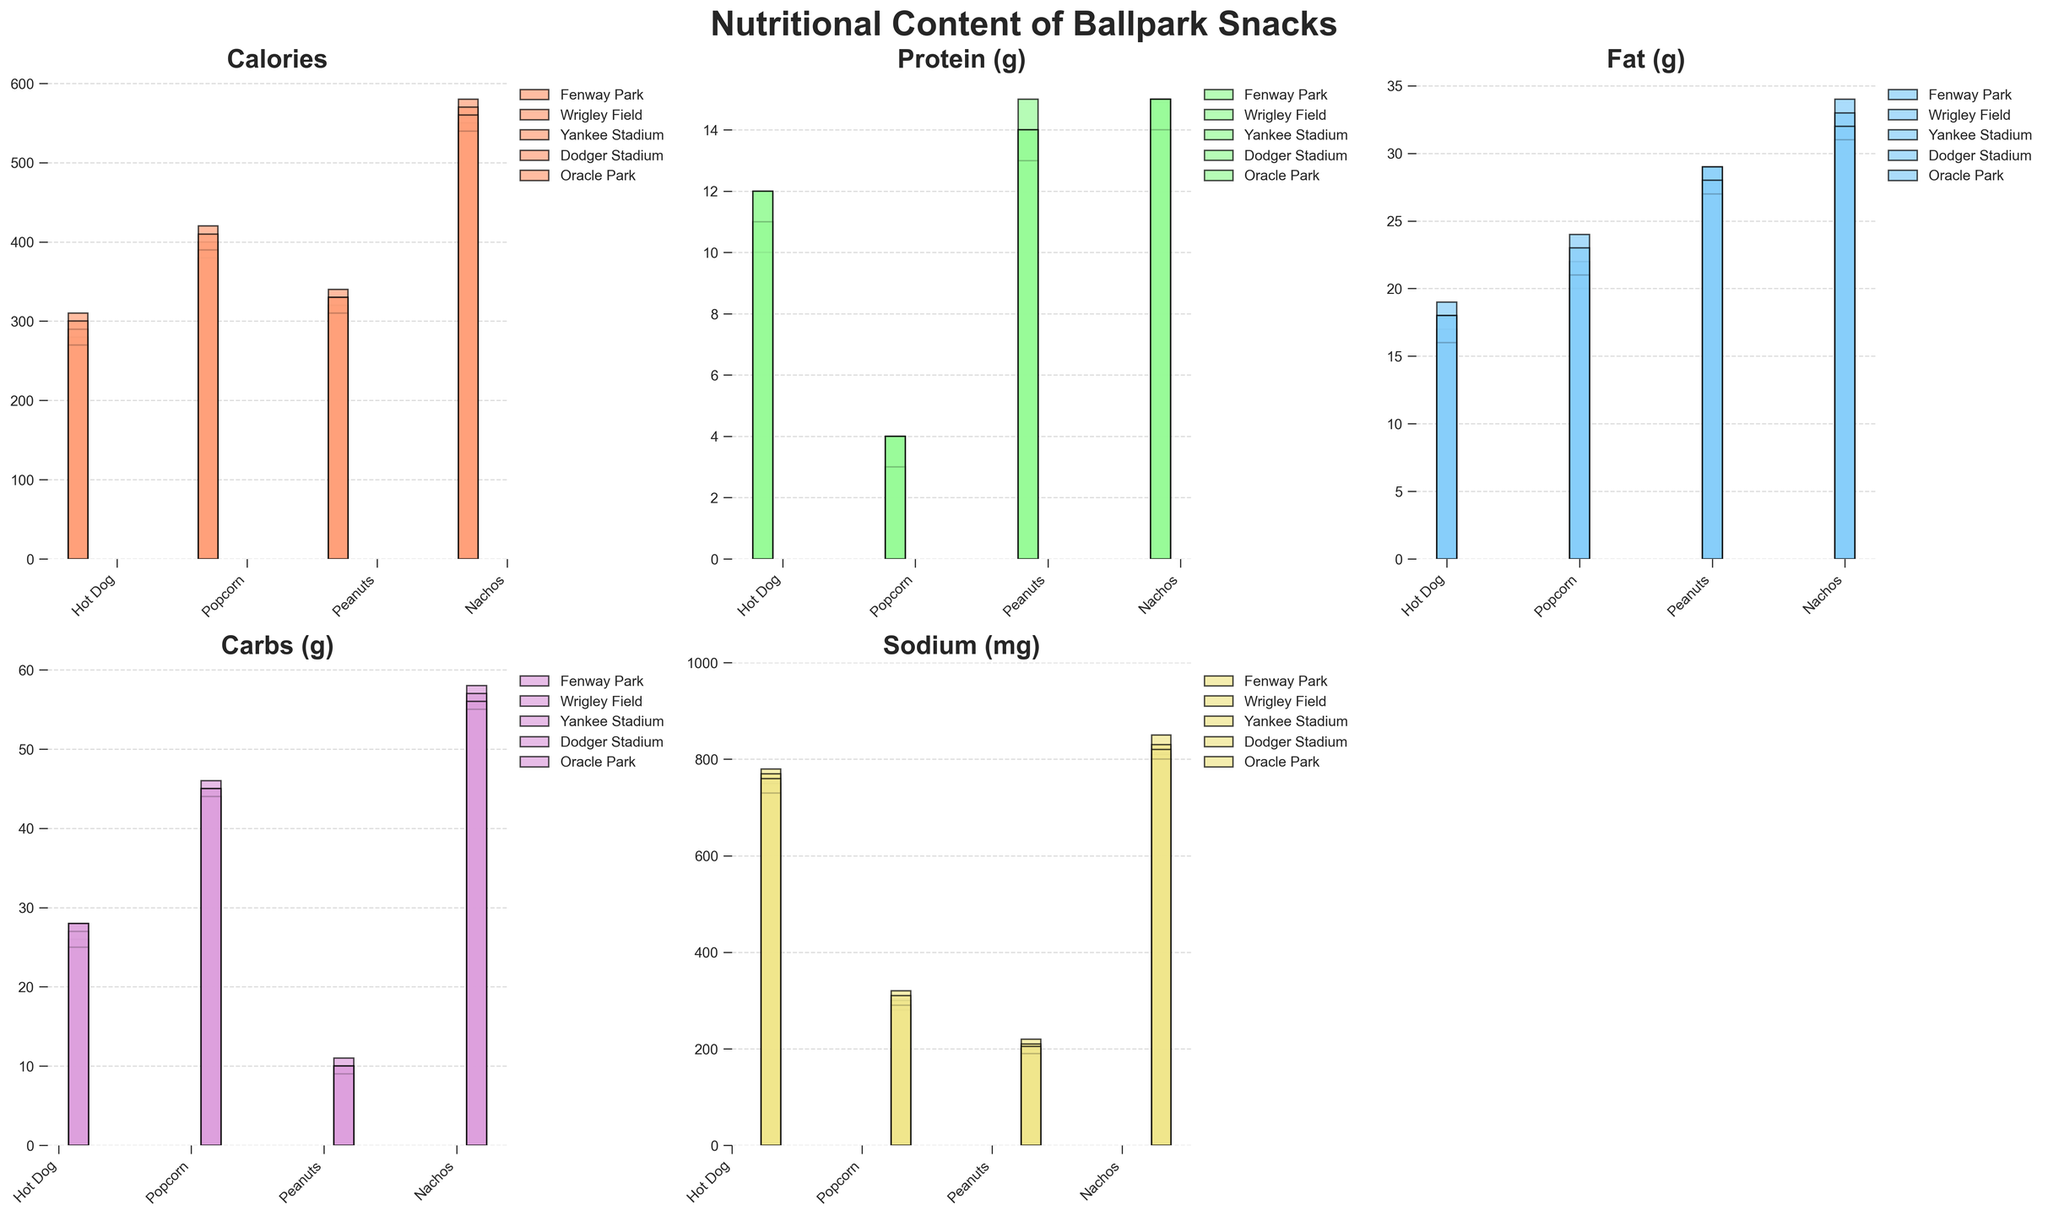Which stadium’s hot dogs have the highest calories? Look at the bar heights for calories of hot dogs in each stadium. The tallest bar represents the highest calories. Fenway Park has the highest calories for hot dogs.
Answer: Fenway Park How much more protein do Fenway Park peanuts have compared to Yankee Stadium peanuts? Compare the protein values of peanuts between Fenway Park and Yankee Stadium by subtracting Yankee Stadium's value from Fenway Park's value: 14g - 14g = 0g.
Answer: 0g Among all stadiums, which snack has the highest sodium content? Look for the tallest bar in the sodium subplot across all snacks and stadiums. Nachos at Wrigley Field have the highest sodium content.
Answer: Nachos at Wrigley Field Which stadium offers the lowest carbohydrate content for popcorn? Compare the bar heights for carbohydrate content for popcorn across all stadiums. Dodger Stadium has the shortest bar, indicating the lowest carbohydrate content.
Answer: Dodger Stadium Considering all snack categories, which stadium provides snacks with the lowest average fat content? Calculate the average fat content for all snacks in each stadium and compare. Add the fat values for each stadium's snacks, divide by 4 (as there are 4 snacks), then identify the smallest average. Dodger Stadium has the lowest average with (16 + 21 + 27 + 31)/4 = 23.75g.
Answer: Dodger Stadium Which stadium’s nachos have the highest protein content, and by how much more than the lowest protein content nachos? Compare protein content for nachos at each stadium. The highest is at Wrigley Field and Yankee Stadium (both 15g), and the lowest is at Fenway Park and Dodger Stadium (both 14g). The difference is 15g - 14g = 1g.
Answer: Wrigley Field and Yankee Stadium, 1g What is the sum of sodium content for all snacks combined at Oracle Park? Add the sodium content of all snacks at Oracle Park: 760 + 310 + 205 + 820. Calculation yields 760 + 310 + 205 + 820 = 2095 mg.
Answer: 2095 mg Which has a higher total fat content: hot dogs in Yankee Stadium or nachos in Fenway Park? By how much? Compare the fat content of hot dogs at Yankee Stadium (18g) with nachos at Fenway Park (32g). 32g - 18g = 14g. Nachos at Fenway Park have a higher total fat content by 14g.
Answer: Nachos in Fenway Park, 14g Which snack typically offers the highest amount of protein across all stadiums? Look for the tallest bars in the protein subplot across all snacks. Peanuts consistently show the highest protein content in each stadium.
Answer: Peanuts 